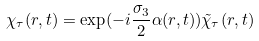Convert formula to latex. <formula><loc_0><loc_0><loc_500><loc_500>\chi _ { \tau } ( r , t ) = \exp ( - i \frac { \sigma _ { 3 } } { 2 } \alpha ( r , t ) ) \tilde { \chi } _ { \tau } ( r , t )</formula> 